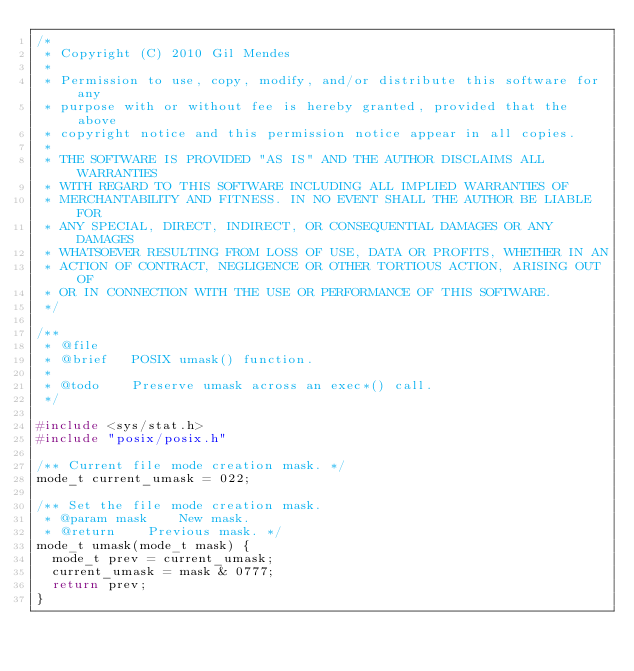<code> <loc_0><loc_0><loc_500><loc_500><_C_>/*
 * Copyright (C) 2010 Gil Mendes
 *
 * Permission to use, copy, modify, and/or distribute this software for any
 * purpose with or without fee is hereby granted, provided that the above
 * copyright notice and this permission notice appear in all copies.
 *
 * THE SOFTWARE IS PROVIDED "AS IS" AND THE AUTHOR DISCLAIMS ALL WARRANTIES
 * WITH REGARD TO THIS SOFTWARE INCLUDING ALL IMPLIED WARRANTIES OF
 * MERCHANTABILITY AND FITNESS. IN NO EVENT SHALL THE AUTHOR BE LIABLE FOR
 * ANY SPECIAL, DIRECT, INDIRECT, OR CONSEQUENTIAL DAMAGES OR ANY DAMAGES
 * WHATSOEVER RESULTING FROM LOSS OF USE, DATA OR PROFITS, WHETHER IN AN
 * ACTION OF CONTRACT, NEGLIGENCE OR OTHER TORTIOUS ACTION, ARISING OUT OF
 * OR IN CONNECTION WITH THE USE OR PERFORMANCE OF THIS SOFTWARE.
 */

/**
 * @file
 * @brief		POSIX umask() function.
 *
 * @todo		Preserve umask across an exec*() call.
 */

#include <sys/stat.h>
#include "posix/posix.h"

/** Current file mode creation mask. */
mode_t current_umask = 022;

/** Set the file mode creation mask.
 * @param mask		New mask.
 * @return		Previous mask. */
mode_t umask(mode_t mask) {
	mode_t prev = current_umask;
	current_umask = mask & 0777;
	return prev;
}
</code> 